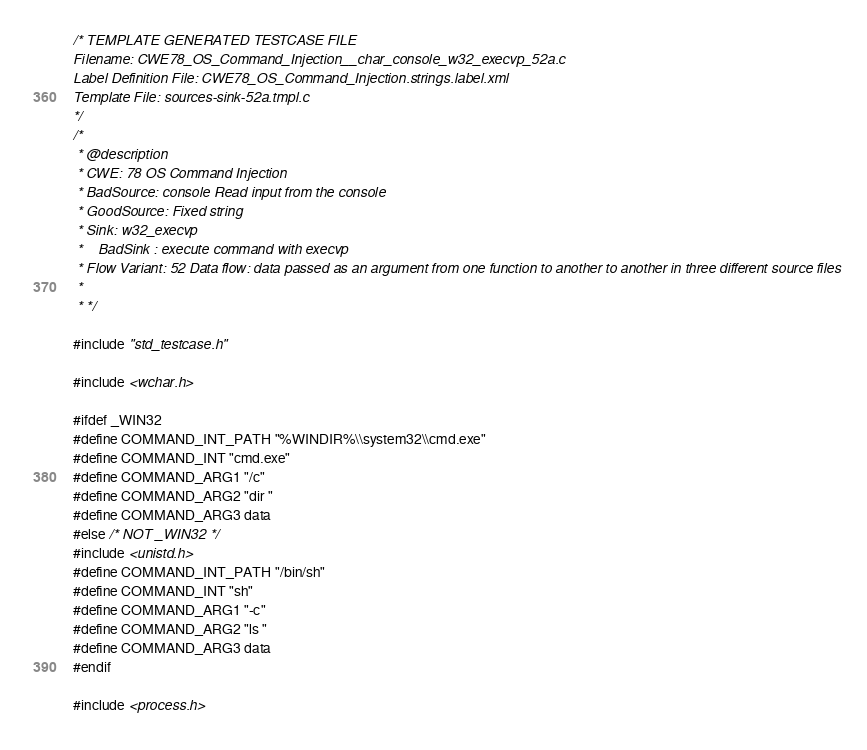Convert code to text. <code><loc_0><loc_0><loc_500><loc_500><_C_>/* TEMPLATE GENERATED TESTCASE FILE
Filename: CWE78_OS_Command_Injection__char_console_w32_execvp_52a.c
Label Definition File: CWE78_OS_Command_Injection.strings.label.xml
Template File: sources-sink-52a.tmpl.c
*/
/*
 * @description
 * CWE: 78 OS Command Injection
 * BadSource: console Read input from the console
 * GoodSource: Fixed string
 * Sink: w32_execvp
 *    BadSink : execute command with execvp
 * Flow Variant: 52 Data flow: data passed as an argument from one function to another to another in three different source files
 *
 * */

#include "std_testcase.h"

#include <wchar.h>

#ifdef _WIN32
#define COMMAND_INT_PATH "%WINDIR%\\system32\\cmd.exe"
#define COMMAND_INT "cmd.exe"
#define COMMAND_ARG1 "/c"
#define COMMAND_ARG2 "dir "
#define COMMAND_ARG3 data
#else /* NOT _WIN32 */
#include <unistd.h>
#define COMMAND_INT_PATH "/bin/sh"
#define COMMAND_INT "sh"
#define COMMAND_ARG1 "-c"
#define COMMAND_ARG2 "ls "
#define COMMAND_ARG3 data
#endif

#include <process.h></code> 